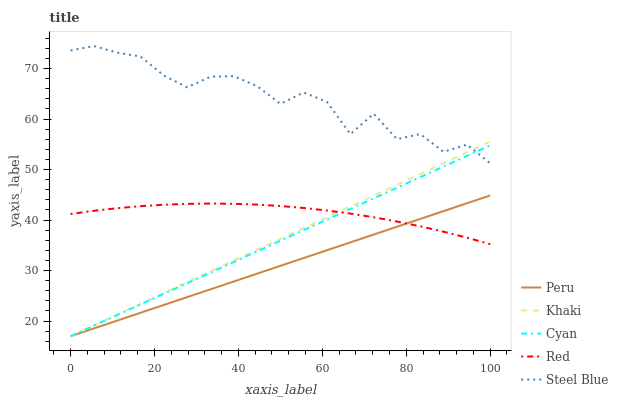Does Peru have the minimum area under the curve?
Answer yes or no. Yes. Does Steel Blue have the maximum area under the curve?
Answer yes or no. Yes. Does Khaki have the minimum area under the curve?
Answer yes or no. No. Does Khaki have the maximum area under the curve?
Answer yes or no. No. Is Cyan the smoothest?
Answer yes or no. Yes. Is Steel Blue the roughest?
Answer yes or no. Yes. Is Khaki the smoothest?
Answer yes or no. No. Is Khaki the roughest?
Answer yes or no. No. Does Cyan have the lowest value?
Answer yes or no. Yes. Does Red have the lowest value?
Answer yes or no. No. Does Steel Blue have the highest value?
Answer yes or no. Yes. Does Khaki have the highest value?
Answer yes or no. No. Is Red less than Steel Blue?
Answer yes or no. Yes. Is Steel Blue greater than Peru?
Answer yes or no. Yes. Does Cyan intersect Khaki?
Answer yes or no. Yes. Is Cyan less than Khaki?
Answer yes or no. No. Is Cyan greater than Khaki?
Answer yes or no. No. Does Red intersect Steel Blue?
Answer yes or no. No. 